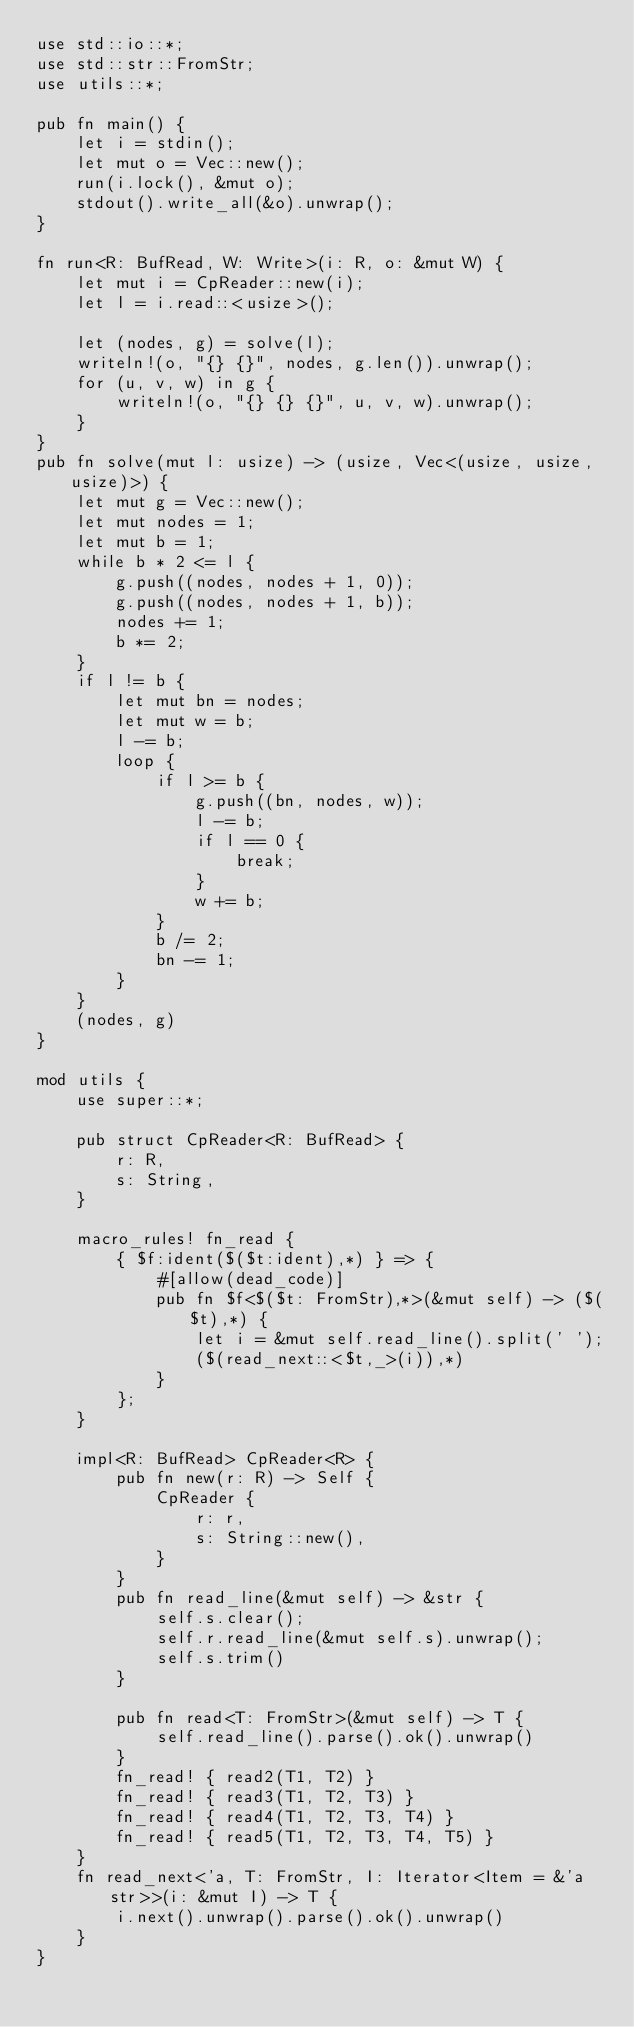Convert code to text. <code><loc_0><loc_0><loc_500><loc_500><_Rust_>use std::io::*;
use std::str::FromStr;
use utils::*;

pub fn main() {
    let i = stdin();
    let mut o = Vec::new();
    run(i.lock(), &mut o);
    stdout().write_all(&o).unwrap();
}

fn run<R: BufRead, W: Write>(i: R, o: &mut W) {
    let mut i = CpReader::new(i);
    let l = i.read::<usize>();

    let (nodes, g) = solve(l);
    writeln!(o, "{} {}", nodes, g.len()).unwrap();
    for (u, v, w) in g {
        writeln!(o, "{} {} {}", u, v, w).unwrap();
    }
}
pub fn solve(mut l: usize) -> (usize, Vec<(usize, usize, usize)>) {
    let mut g = Vec::new();
    let mut nodes = 1;
    let mut b = 1;
    while b * 2 <= l {
        g.push((nodes, nodes + 1, 0));
        g.push((nodes, nodes + 1, b));
        nodes += 1;
        b *= 2;
    }
    if l != b {
        let mut bn = nodes;
        let mut w = b;
        l -= b;
        loop {
            if l >= b {
                g.push((bn, nodes, w));
                l -= b;
                if l == 0 {
                    break;
                }
                w += b;
            }
            b /= 2;
            bn -= 1;
        }
    }
    (nodes, g)
}

mod utils {
    use super::*;

    pub struct CpReader<R: BufRead> {
        r: R,
        s: String,
    }

    macro_rules! fn_read {
        { $f:ident($($t:ident),*) } => {
            #[allow(dead_code)]
            pub fn $f<$($t: FromStr),*>(&mut self) -> ($($t),*) {
                let i = &mut self.read_line().split(' ');
                ($(read_next::<$t,_>(i)),*)
            }
        };
    }

    impl<R: BufRead> CpReader<R> {
        pub fn new(r: R) -> Self {
            CpReader {
                r: r,
                s: String::new(),
            }
        }
        pub fn read_line(&mut self) -> &str {
            self.s.clear();
            self.r.read_line(&mut self.s).unwrap();
            self.s.trim()
        }

        pub fn read<T: FromStr>(&mut self) -> T {
            self.read_line().parse().ok().unwrap()
        }
        fn_read! { read2(T1, T2) }
        fn_read! { read3(T1, T2, T3) }
        fn_read! { read4(T1, T2, T3, T4) }
        fn_read! { read5(T1, T2, T3, T4, T5) }
    }
    fn read_next<'a, T: FromStr, I: Iterator<Item = &'a str>>(i: &mut I) -> T {
        i.next().unwrap().parse().ok().unwrap()
    }
}
</code> 